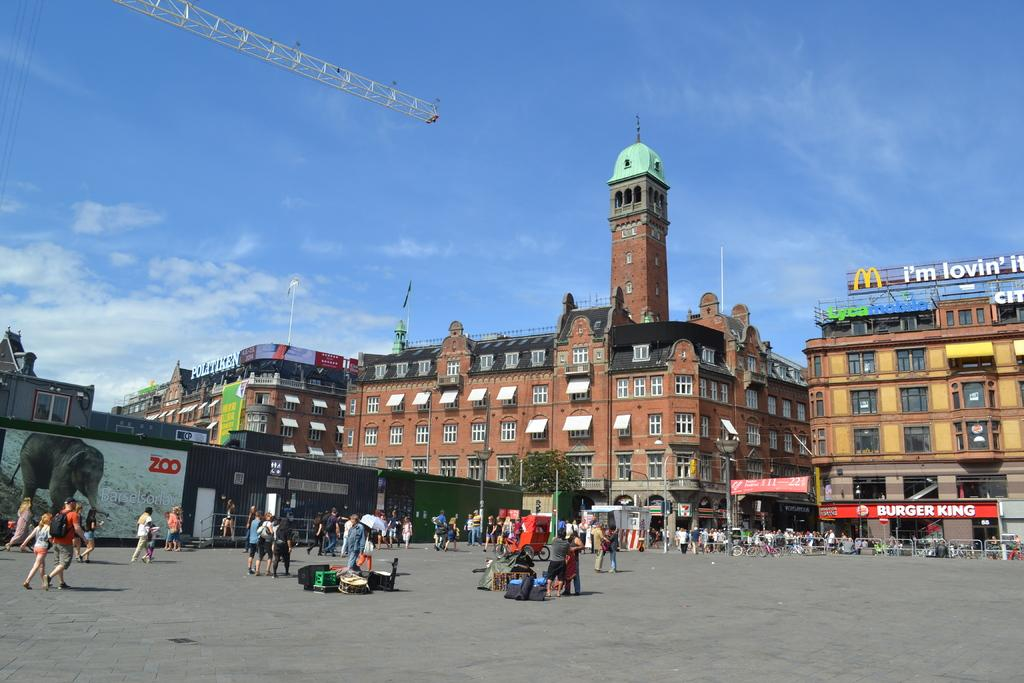What are the people in the image doing? There is a group of people walking on a path in the image. Are there any people not walking in the image? Yes, some people are standing in the image. What can be seen in the background of the image? There are poles, trees, buildings, and the sky visible in the background of the image. What type of skin condition can be seen on the people in the image? There is no indication of any skin condition on the people in the image. Is there an island visible in the image? No, there is no island present in the image. 